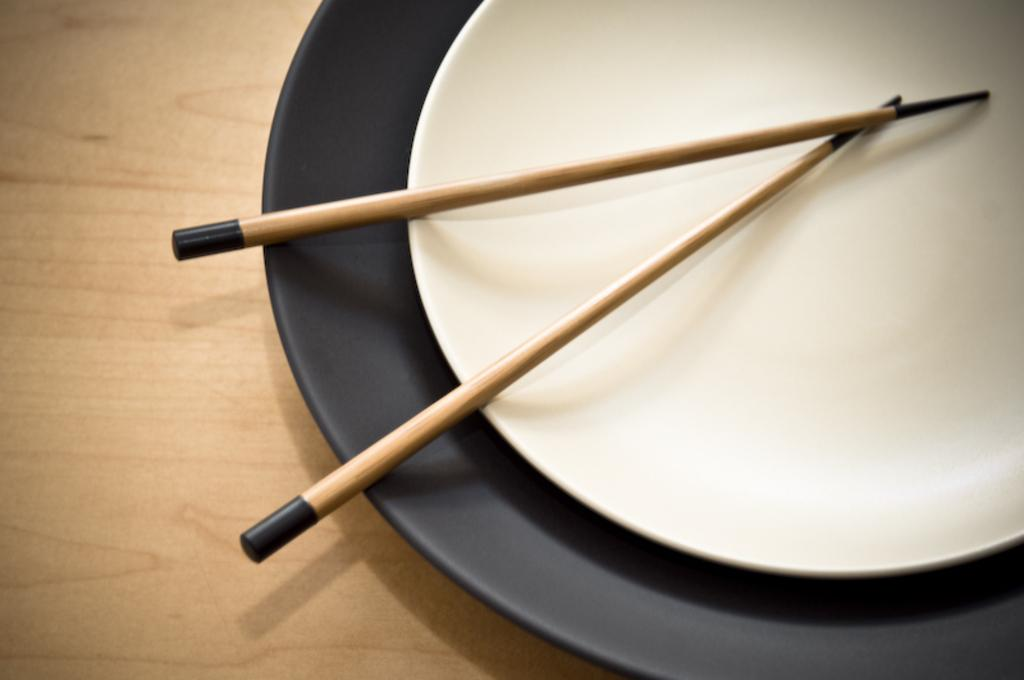What objects are on the right side of the image? There are two plates and chopsticks on the right side of the image. What can be seen on the left side of the image? There is a table on the left side of the image. What type of science experiment is being conducted by the woman in the image? There is no woman or science experiment present in the image. 